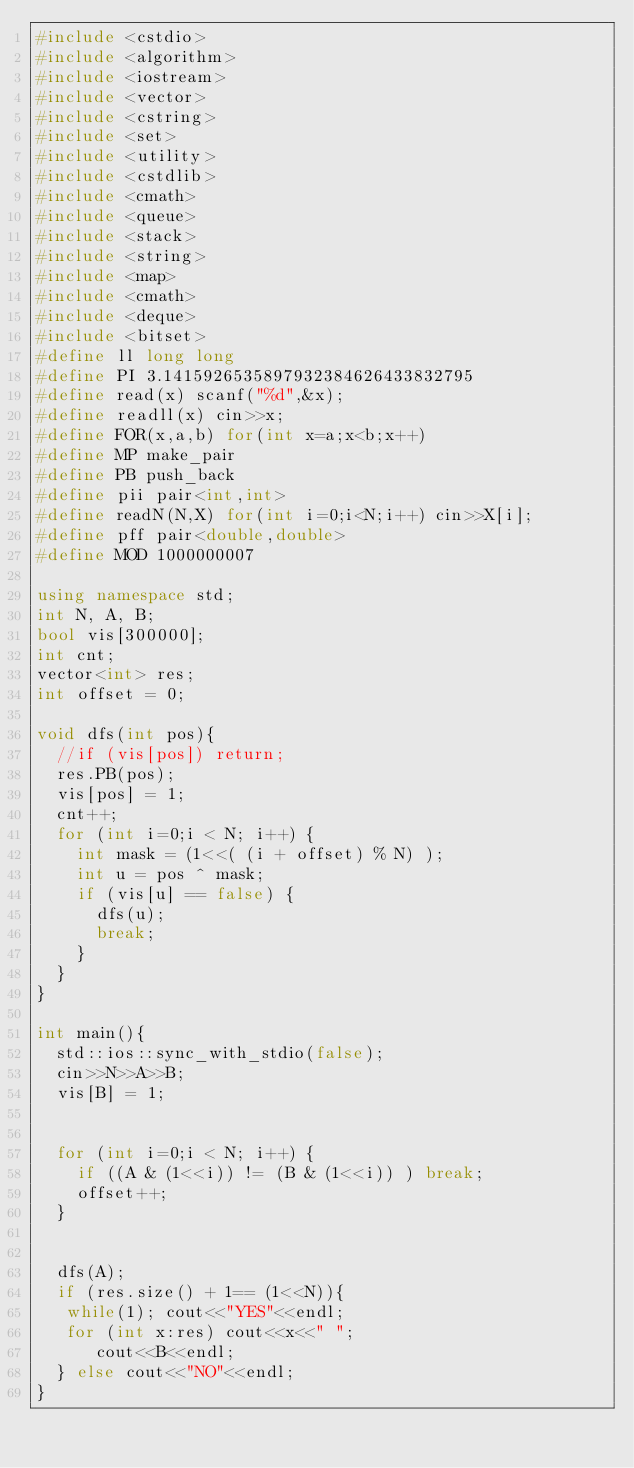Convert code to text. <code><loc_0><loc_0><loc_500><loc_500><_C++_>#include <cstdio>
#include <algorithm>
#include <iostream>
#include <vector>
#include <cstring>
#include <set>
#include <utility>
#include <cstdlib>
#include <cmath>
#include <queue>
#include <stack>
#include <string>
#include <map>
#include <cmath>
#include <deque>
#include <bitset>
#define ll long long
#define PI 3.1415926535897932384626433832795
#define read(x) scanf("%d",&x);
#define readll(x) cin>>x;
#define FOR(x,a,b) for(int x=a;x<b;x++)
#define MP make_pair
#define PB push_back
#define pii pair<int,int>
#define readN(N,X) for(int i=0;i<N;i++) cin>>X[i];
#define pff pair<double,double>
#define MOD 1000000007

using namespace std;
int N, A, B;
bool vis[300000];
int cnt;
vector<int> res;
int offset = 0;

void dfs(int pos){
  //if (vis[pos]) return;
  res.PB(pos);
  vis[pos] = 1;
  cnt++;
  for (int i=0;i < N; i++) {
    int mask = (1<<( (i + offset) % N) );
    int u = pos ^ mask;
    if (vis[u] == false) {
      dfs(u);
      break;
    }
  }
}

int main(){
  std::ios::sync_with_stdio(false); 
  cin>>N>>A>>B;
  vis[B] = 1;


  for (int i=0;i < N; i++) {
    if ((A & (1<<i)) != (B & (1<<i)) ) break;
    offset++;
  }


  dfs(A);
  if (res.size() + 1== (1<<N)){
   while(1); cout<<"YES"<<endl;
   for (int x:res) cout<<x<<" ";
      cout<<B<<endl;
  } else cout<<"NO"<<endl;
}


</code> 